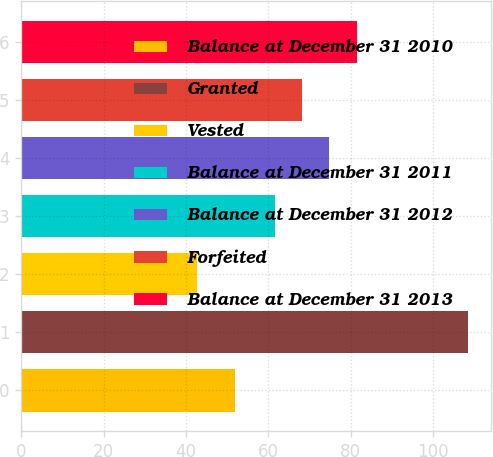<chart> <loc_0><loc_0><loc_500><loc_500><bar_chart><fcel>Balance at December 31 2010<fcel>Granted<fcel>Vested<fcel>Balance at December 31 2011<fcel>Balance at December 31 2012<fcel>Forfeited<fcel>Balance at December 31 2013<nl><fcel>51.94<fcel>108.51<fcel>42.61<fcel>61.49<fcel>74.67<fcel>68.08<fcel>81.49<nl></chart> 